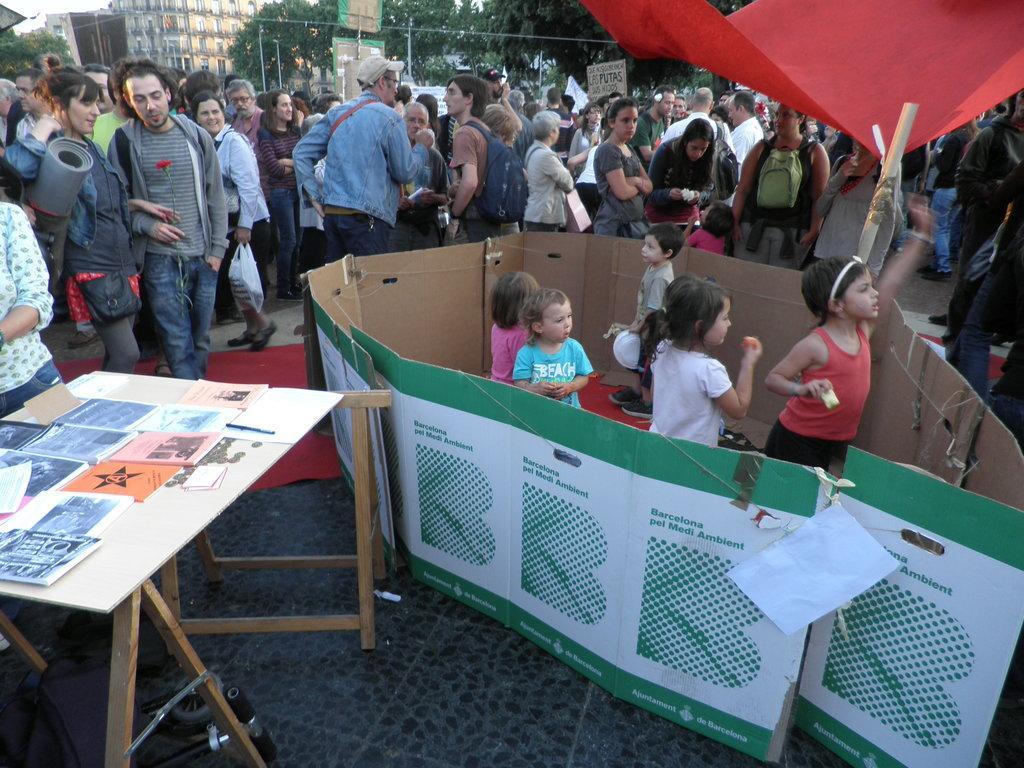Can you describe this image briefly? This picture shows a group of people standing and we see a table and we see some papers on it and we see few kids standing and we see buildings and trees around 